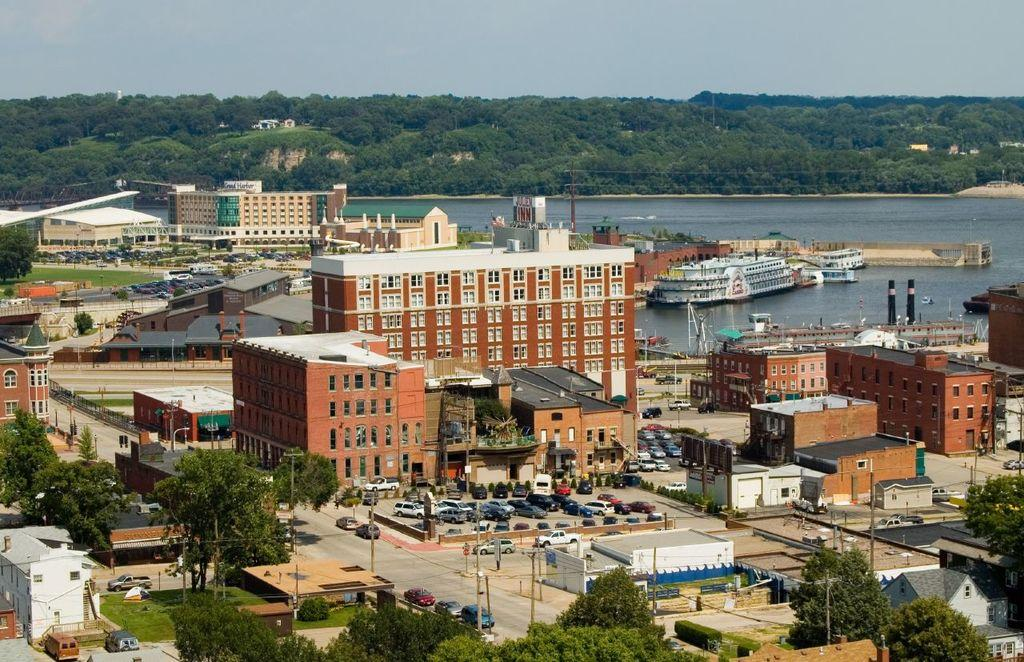What is located in the center of the image? There are buildings in the center of the image. What is at the bottom of the image? There is a road at the bottom of the image, along with trees and poles. What can be seen on the road? Cars are visible on the road. What is present in the background of the image? There is a river, trees, and the sky visible in the background of the image. What is in the river? A boat is present in the river. What type of health issues are the trees experiencing in the image? There is no indication of any health issues affecting the trees in the image. What color is the shirt worn by the boat in the image? There is no boat wearing a shirt in the image; it is a regular boat in the river. 